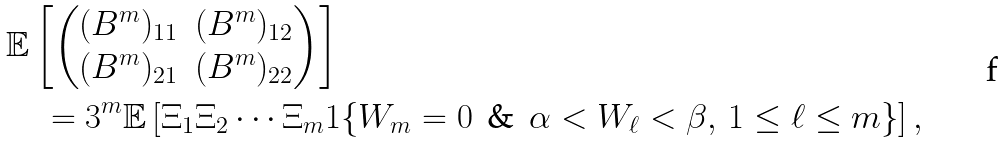<formula> <loc_0><loc_0><loc_500><loc_500>& \mathbb { E } \left [ \begin{pmatrix} ( B ^ { m } ) _ { 1 1 } & ( B ^ { m } ) _ { 1 2 } \\ ( B ^ { m } ) _ { 2 1 } & ( B ^ { m } ) _ { 2 2 } \end{pmatrix} \right ] \\ & \quad = 3 ^ { m } \mathbb { E } \left [ \Xi _ { 1 } \Xi _ { 2 } \cdots \Xi _ { m } 1 \{ W _ { m } = 0 \, \text { \& } \, \alpha < W _ { \ell } < \beta , \, 1 \leq \ell \leq m \} \right ] , \\</formula> 